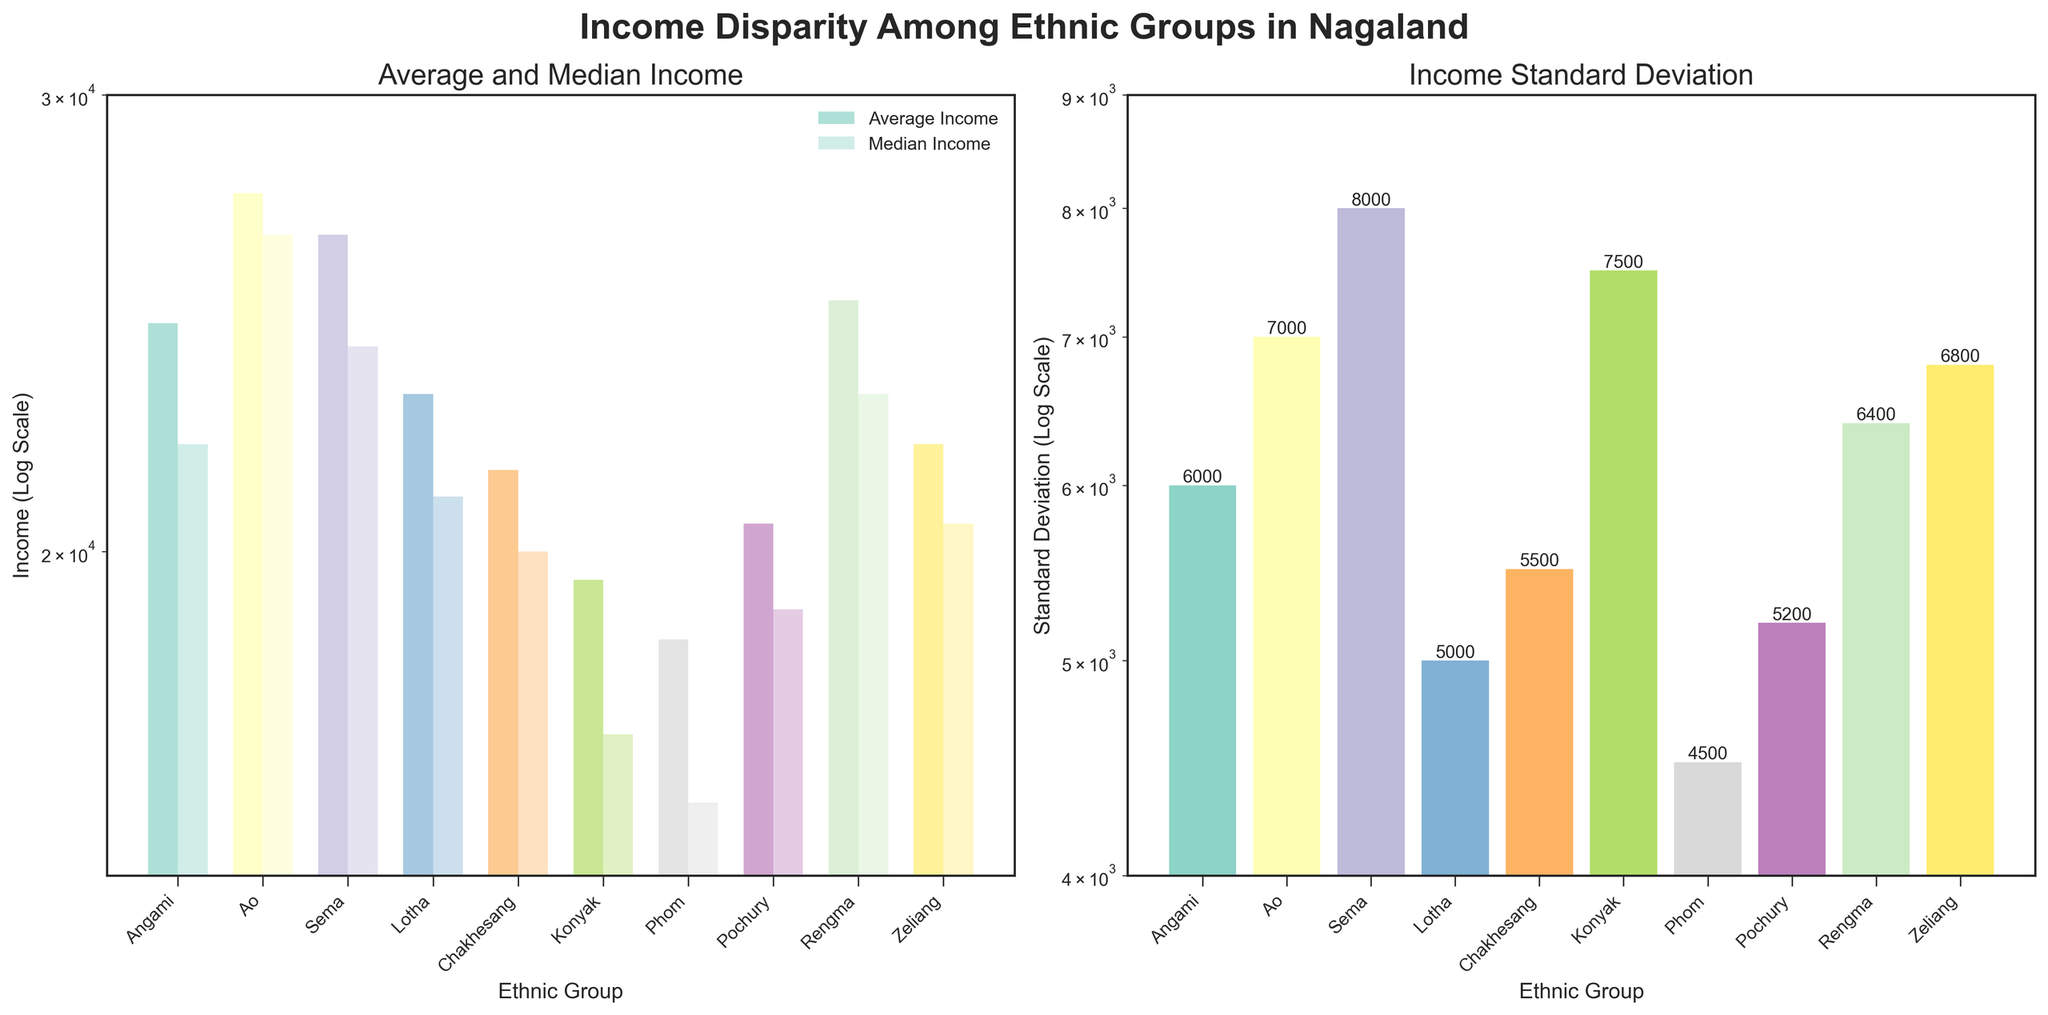How many ethnic groups are compared in the figure? Simply count the number of unique ethnic groups displayed on the x-axis.
Answer: 10 Which ethnic group has the highest average income? Refer to the height of bars representing average income in the first subplot. The ethnic group with the tallest bar for average income has the highest average income.
Answer: Ao What is the median income for the Chakhesang ethnic group? Locate the Chakhesang bar on the first subplot and identify the height of the lighter/shaded bar representing the median income.
Answer: 20000 Which ethnic group shows the greatest income disparity (standard deviation)? Check the heights of the bars in the second subplot. The bar with the highest value represents the greatest standard deviation.
Answer: Sema Is the average income of the Angami ethnic group higher or lower than that of the Rengma ethnic group? Compare the height of the Angami average income bar to that of the Rengma average income bar in the first subplot. The bar that is taller indicates a higher average income.
Answer: Lower Identify which group has closer average and median incomes by comparison. Examine the first subplot to find the ethnic groups where the differences between the heights of the average income bar and the median income bar are smaller.
Answer: Ao What is the standard deviation of income for the Pochury ethnic group? Locate the Pochury bar in the second subplot and read the corresponding height to find the standard deviation.
Answer: 5200 Which two ethnic groups have the closest median incomes? Look for bars in the first subplot with similar heights for their median income representation. Comparing closely, it's evident which groups' median incomes are most similar.
Answer: Chakhesang and Zeliang How does the income disparity for Lotha compare to the disparity for Phom? In the second subplot, compare the height of the Lotha bar to the Phom bar. The group with a taller bar has greater income disparity.
Answer: Higher Which ethnic groups have both average and median incomes lower than 25000? Identify all bars in the first subplot where both average and median incomes fall below 25000.
Answer: Chakhesang, Konyak, Phom, Pochury, Zeliang 